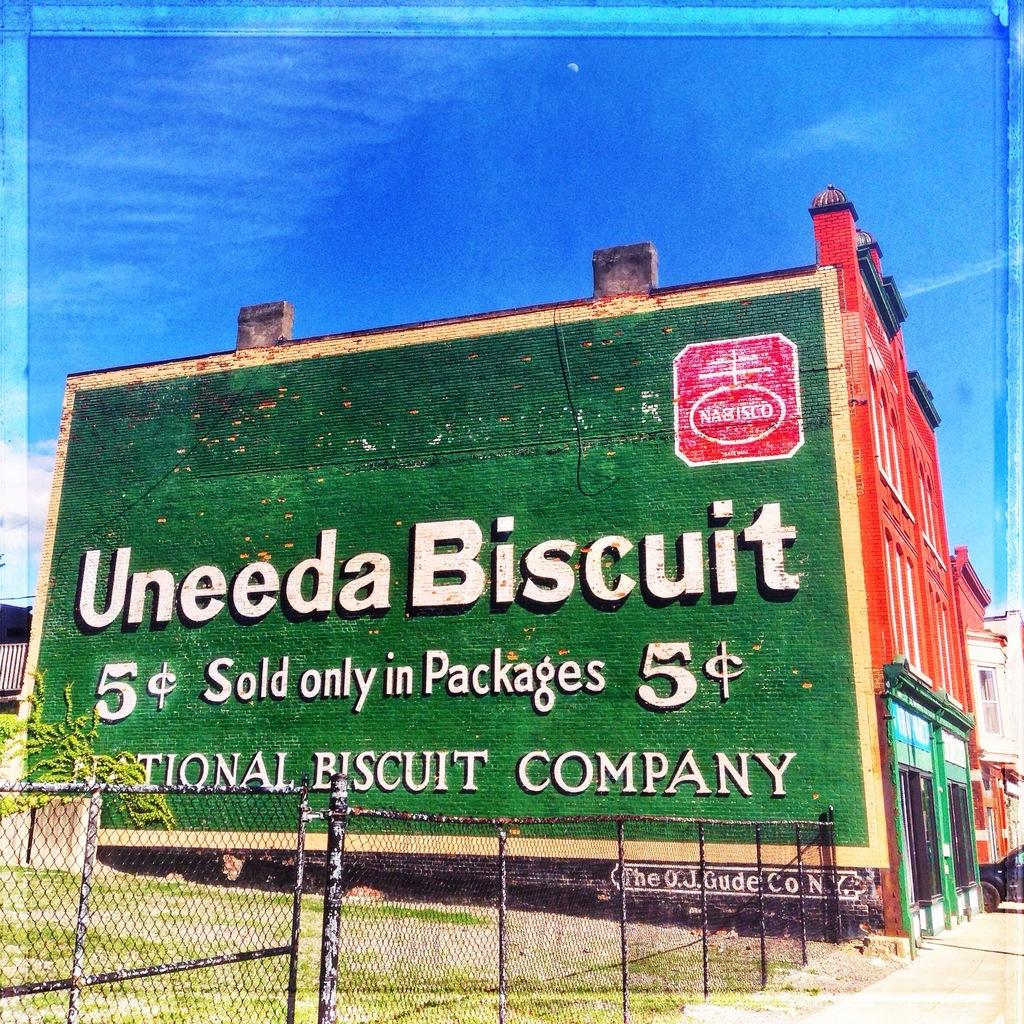<image>
Create a compact narrative representing the image presented. A giant billboard painted on the side of a building advertising Nabisco 